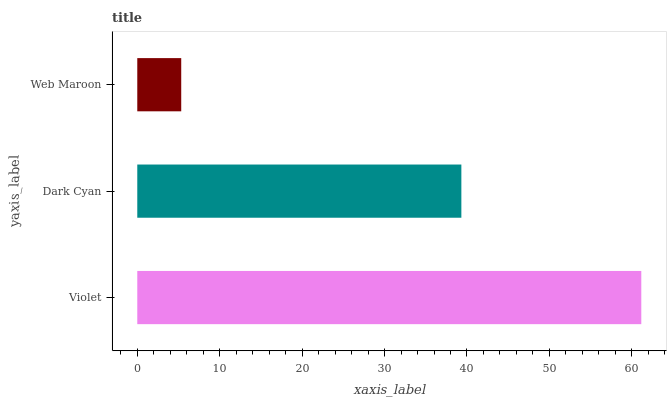Is Web Maroon the minimum?
Answer yes or no. Yes. Is Violet the maximum?
Answer yes or no. Yes. Is Dark Cyan the minimum?
Answer yes or no. No. Is Dark Cyan the maximum?
Answer yes or no. No. Is Violet greater than Dark Cyan?
Answer yes or no. Yes. Is Dark Cyan less than Violet?
Answer yes or no. Yes. Is Dark Cyan greater than Violet?
Answer yes or no. No. Is Violet less than Dark Cyan?
Answer yes or no. No. Is Dark Cyan the high median?
Answer yes or no. Yes. Is Dark Cyan the low median?
Answer yes or no. Yes. Is Violet the high median?
Answer yes or no. No. Is Violet the low median?
Answer yes or no. No. 